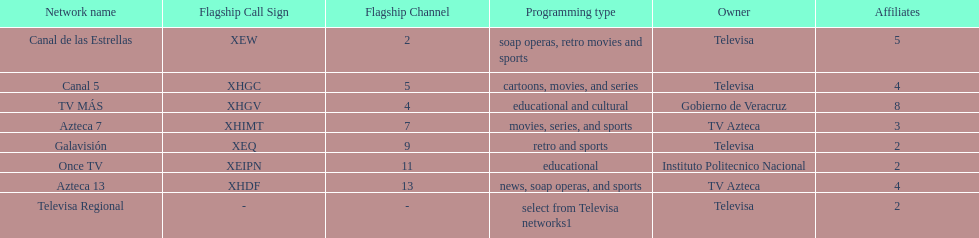How many networks show soap operas? 2. 